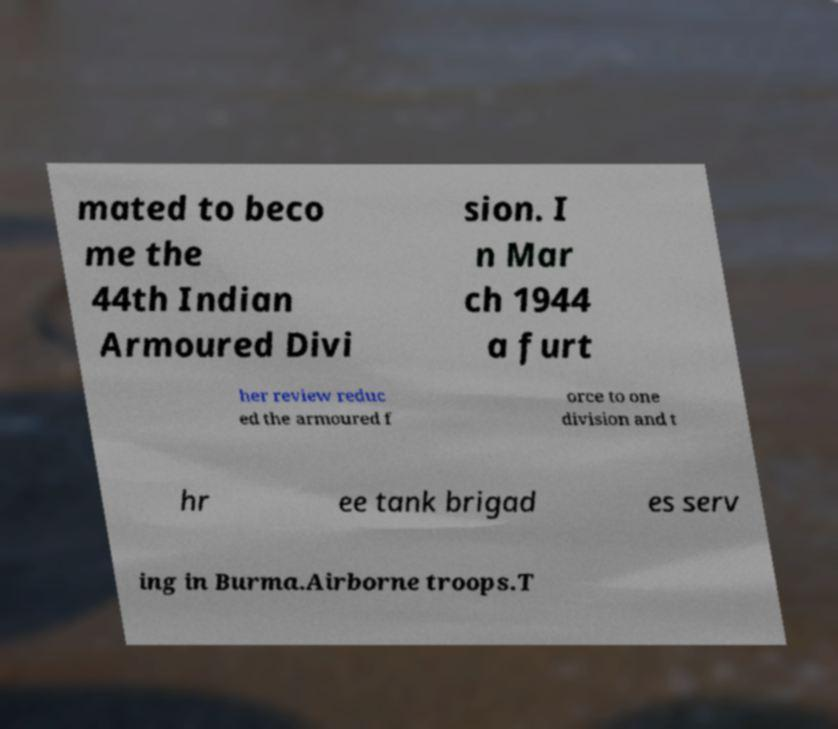There's text embedded in this image that I need extracted. Can you transcribe it verbatim? mated to beco me the 44th Indian Armoured Divi sion. I n Mar ch 1944 a furt her review reduc ed the armoured f orce to one division and t hr ee tank brigad es serv ing in Burma.Airborne troops.T 